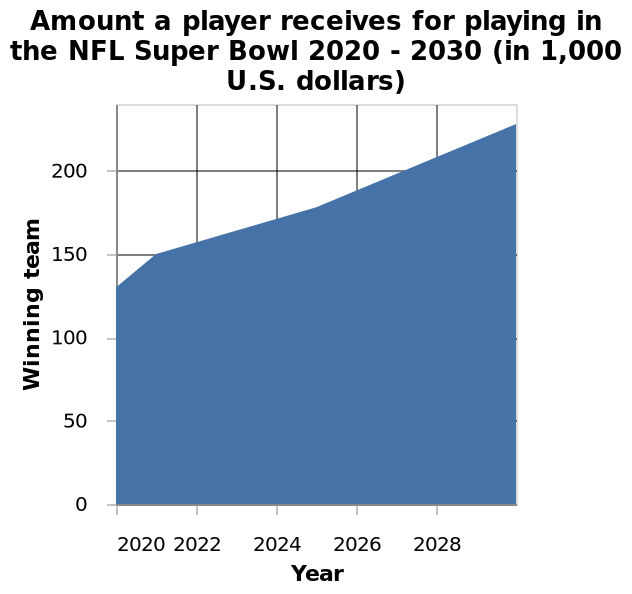<image>
What is the range of years represented on the x-axis of the area diagram?  The range of years represented on the x-axis of the area diagram is from 2020 to 2028. 